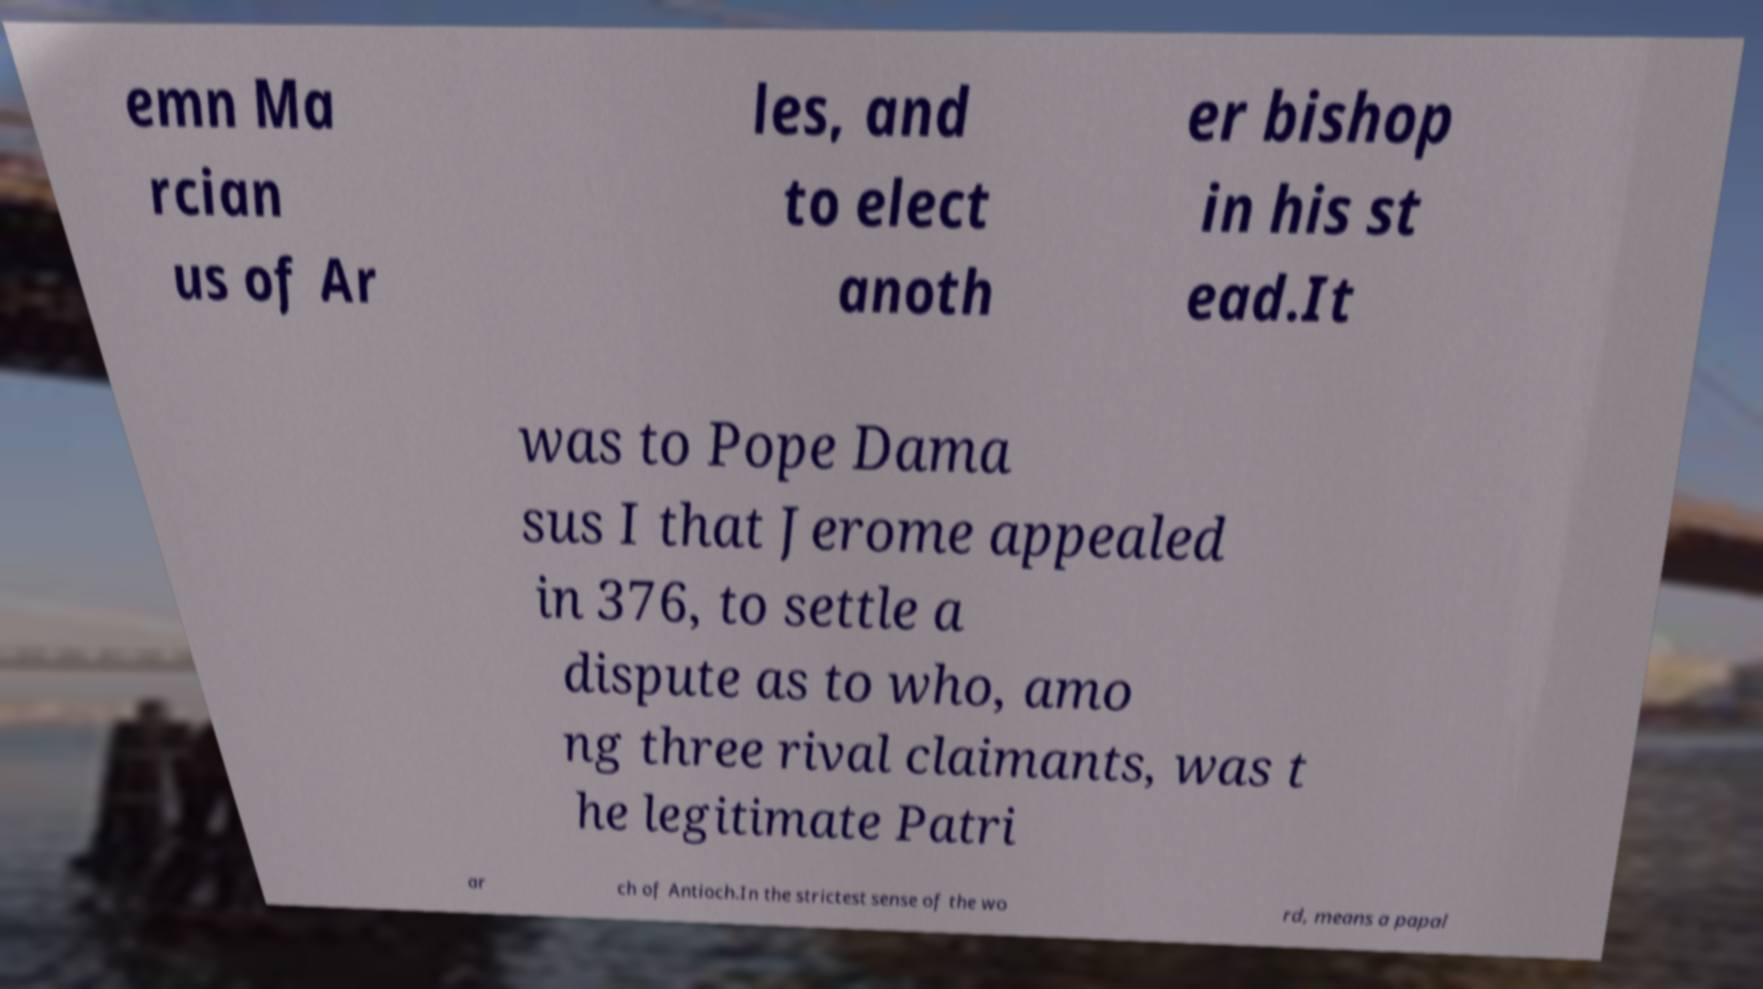I need the written content from this picture converted into text. Can you do that? emn Ma rcian us of Ar les, and to elect anoth er bishop in his st ead.It was to Pope Dama sus I that Jerome appealed in 376, to settle a dispute as to who, amo ng three rival claimants, was t he legitimate Patri ar ch of Antioch.In the strictest sense of the wo rd, means a papal 